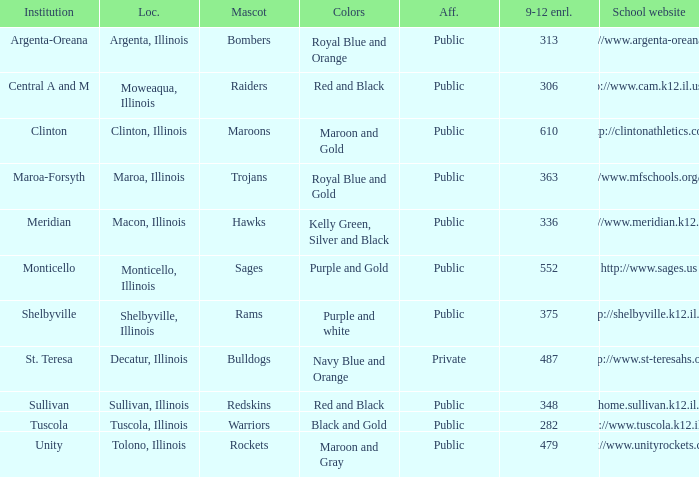What's the website of the school in Macon, Illinois? Http://www.meridian.k12.il.us/. Would you mind parsing the complete table? {'header': ['Institution', 'Loc.', 'Mascot', 'Colors', 'Aff.', '9-12 enrl.', 'School website'], 'rows': [['Argenta-Oreana', 'Argenta, Illinois', 'Bombers', 'Royal Blue and Orange', 'Public', '313', 'http://www.argenta-oreana.org'], ['Central A and M', 'Moweaqua, Illinois', 'Raiders', 'Red and Black', 'Public', '306', 'http://www.cam.k12.il.us/hs'], ['Clinton', 'Clinton, Illinois', 'Maroons', 'Maroon and Gold', 'Public', '610', 'http://clintonathletics.com'], ['Maroa-Forsyth', 'Maroa, Illinois', 'Trojans', 'Royal Blue and Gold', 'Public', '363', 'http://www.mfschools.org/high/'], ['Meridian', 'Macon, Illinois', 'Hawks', 'Kelly Green, Silver and Black', 'Public', '336', 'http://www.meridian.k12.il.us/'], ['Monticello', 'Monticello, Illinois', 'Sages', 'Purple and Gold', 'Public', '552', 'http://www.sages.us'], ['Shelbyville', 'Shelbyville, Illinois', 'Rams', 'Purple and white', 'Public', '375', 'http://shelbyville.k12.il.us/'], ['St. Teresa', 'Decatur, Illinois', 'Bulldogs', 'Navy Blue and Orange', 'Private', '487', 'http://www.st-teresahs.org/'], ['Sullivan', 'Sullivan, Illinois', 'Redskins', 'Red and Black', 'Public', '348', 'http://home.sullivan.k12.il.us/shs'], ['Tuscola', 'Tuscola, Illinois', 'Warriors', 'Black and Gold', 'Public', '282', 'http://www.tuscola.k12.il.us/'], ['Unity', 'Tolono, Illinois', 'Rockets', 'Maroon and Gray', 'Public', '479', 'http://www.unityrockets.com/']]} 